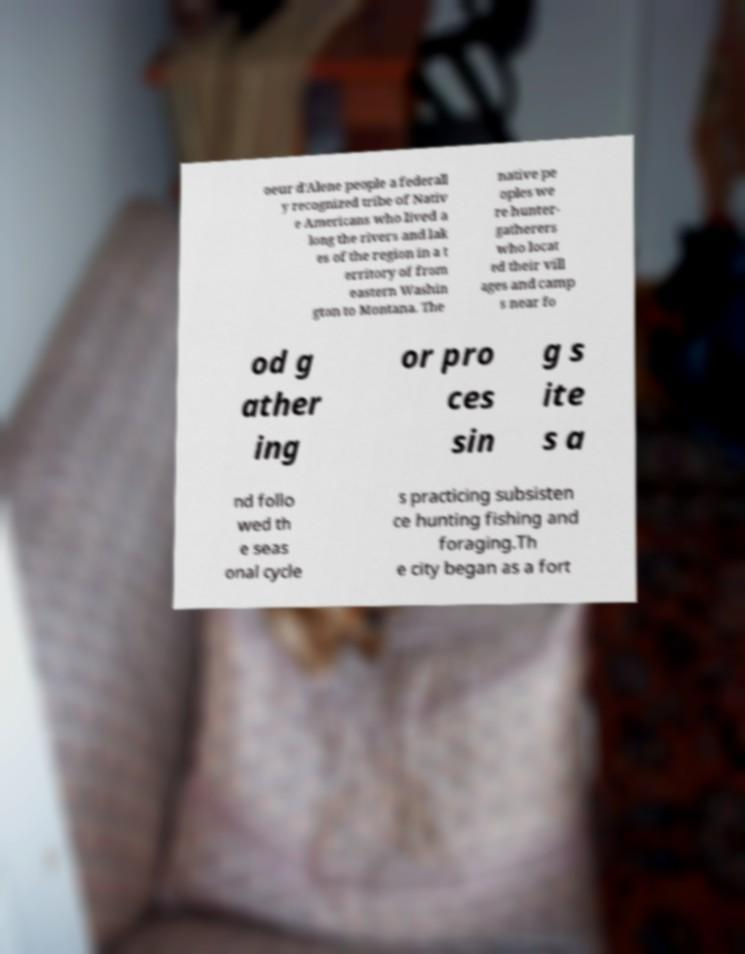Can you accurately transcribe the text from the provided image for me? oeur d'Alene people a federall y recognized tribe of Nativ e Americans who lived a long the rivers and lak es of the region in a t erritory of from eastern Washin gton to Montana. The native pe oples we re hunter- gatherers who locat ed their vill ages and camp s near fo od g ather ing or pro ces sin g s ite s a nd follo wed th e seas onal cycle s practicing subsisten ce hunting fishing and foraging.Th e city began as a fort 